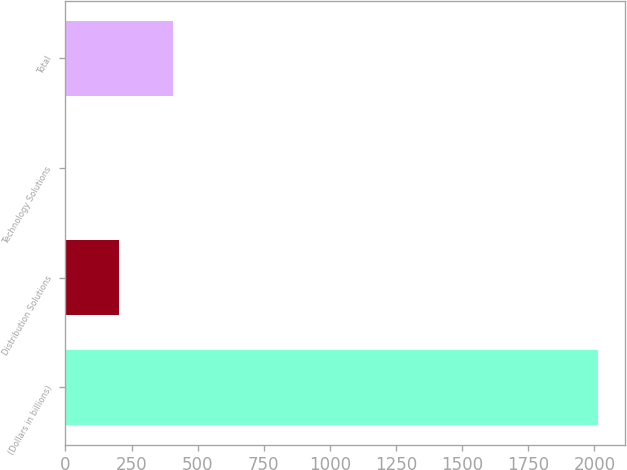Convert chart to OTSL. <chart><loc_0><loc_0><loc_500><loc_500><bar_chart><fcel>(Dollars in billions)<fcel>Distribution Solutions<fcel>Technology Solutions<fcel>Total<nl><fcel>2014<fcel>204.28<fcel>3.2<fcel>405.36<nl></chart> 